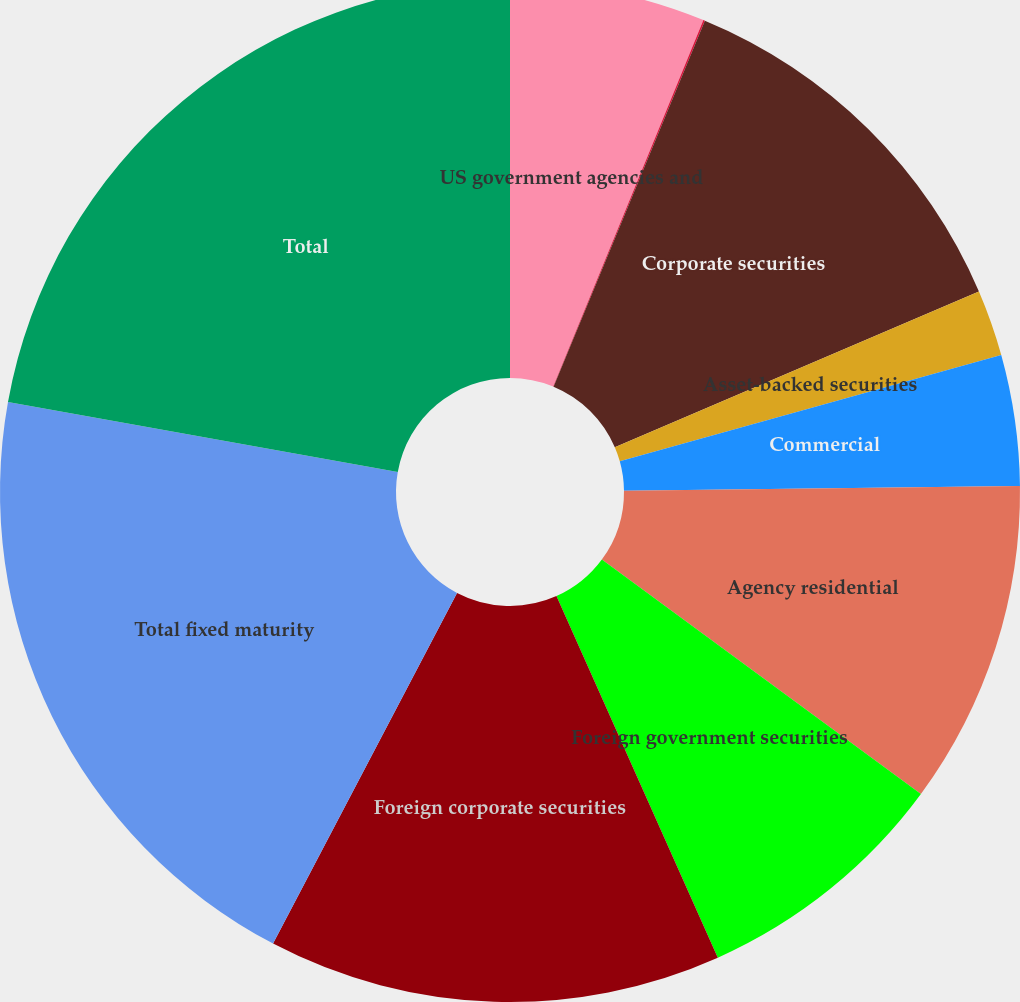<chart> <loc_0><loc_0><loc_500><loc_500><pie_chart><fcel>US government agencies and<fcel>Obligations of US states and<fcel>Corporate securities<fcel>Asset-backed securities<fcel>Commercial<fcel>Agency residential<fcel>Foreign government securities<fcel>Foreign corporate securities<fcel>Total fixed maturity<fcel>Total<nl><fcel>6.19%<fcel>0.05%<fcel>12.33%<fcel>2.1%<fcel>4.14%<fcel>10.28%<fcel>8.23%<fcel>14.37%<fcel>20.13%<fcel>22.18%<nl></chart> 